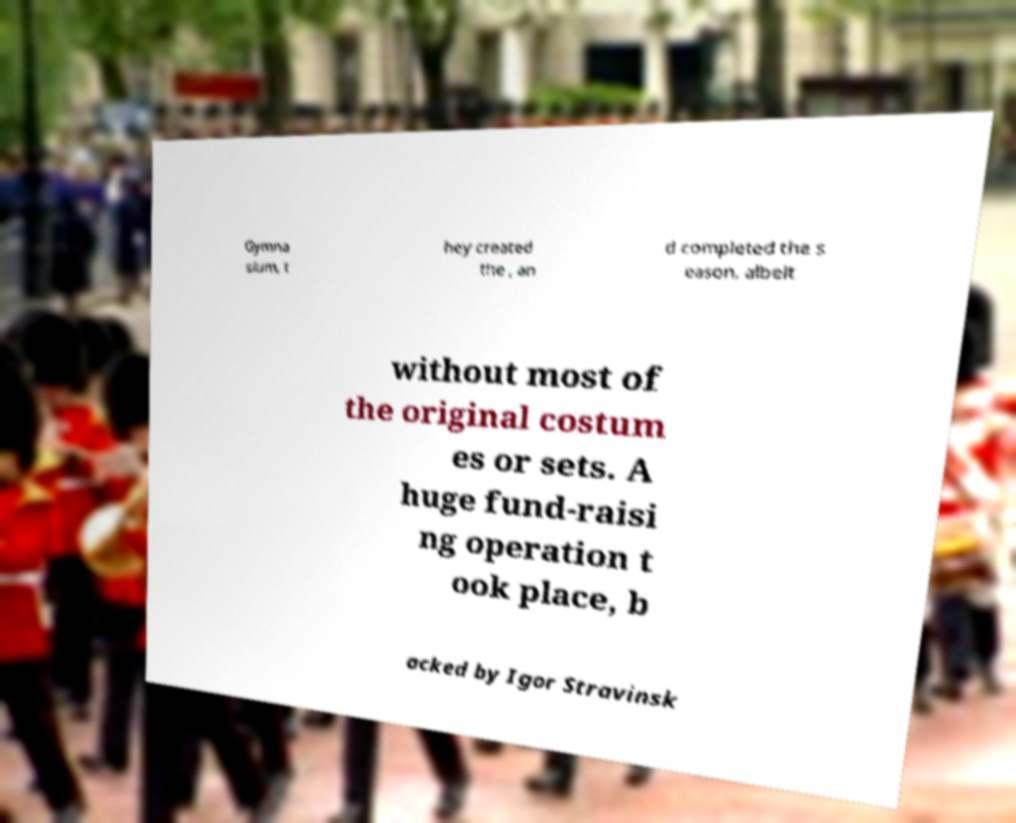Can you read and provide the text displayed in the image?This photo seems to have some interesting text. Can you extract and type it out for me? Gymna sium, t hey created the , an d completed the s eason, albeit without most of the original costum es or sets. A huge fund-raisi ng operation t ook place, b acked by Igor Stravinsk 